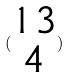Convert formula to latex. <formula><loc_0><loc_0><loc_500><loc_500>( \begin{matrix} 1 3 \\ 4 \end{matrix} )</formula> 